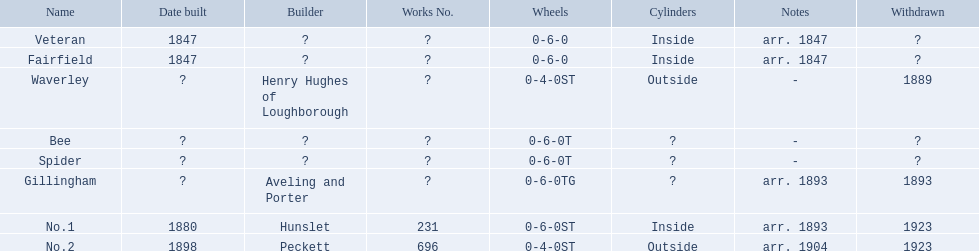What is the aldernay railway system? Veteran, Fairfield, Waverley, Bee, Spider, Gillingham, No.1, No.2. Which railways were constructed in 1847? Veteran, Fairfield. Among them, which one isn't fairfield? Veteran. 